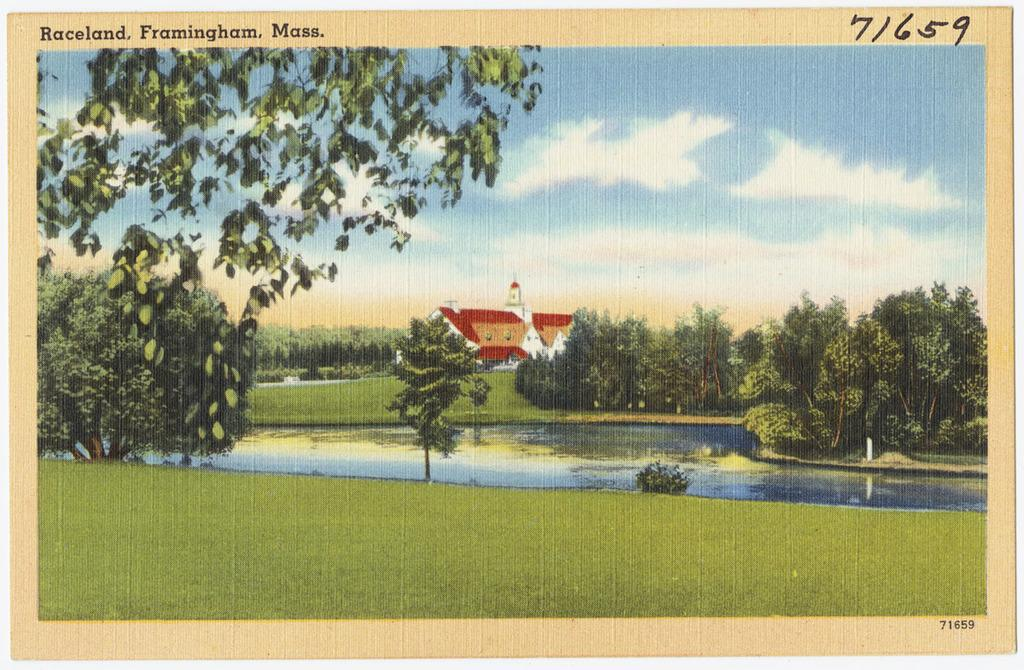What type of visual representation is shown in the image? The image is a poster. What is the main subject depicted on the poster? There is a house depicted on the poster. What natural elements are present in the scene on the poster? There is a lake, trees, plants, and grass depicted on the poster. What type of cloth is used to make the list on the poster? There is no list or cloth present in the image; it is a poster depicting a house, lake, trees, plants, and grass. 